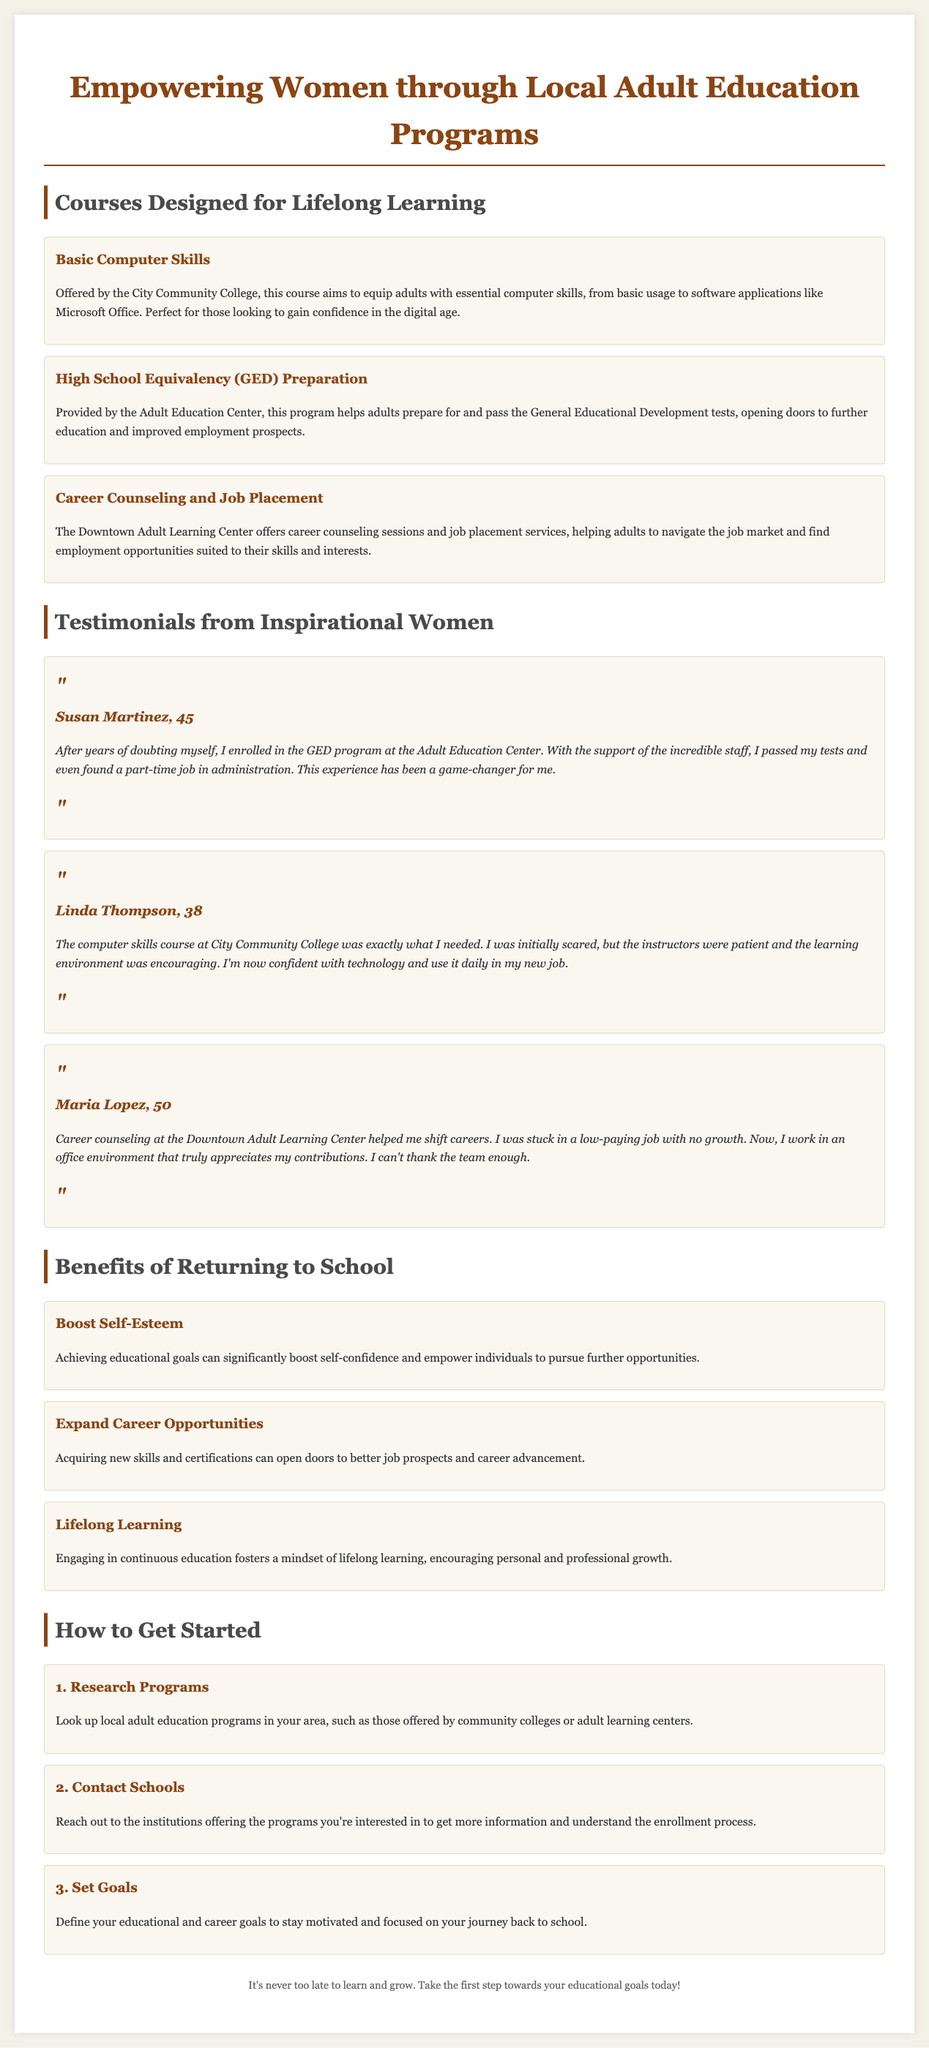What is the title of the document? The title is prominently displayed at the top of the document highlighting the main theme.
Answer: Empowering Women through Local Adult Education Programs How many courses are listed in the document? The document specifies three distinct courses offered for adult education.
Answer: 3 Who is the testimonial from Linda Thompson? The testimonial features an individual named Linda Thompson sharing her experience.
Answer: Linda Thompson What is one benefit of returning to school mentioned in the document? The document lists several benefits, one of which is prominently highlighted in the benefits section.
Answer: Boost Self-Esteem What is the first step to get started with adult education programs? The document outlines a specific order of steps to begin the process of returning to education.
Answer: Research Programs What age is Susan Martinez? The testimonial includes personal details such as age, specifically about Susan Martinez.
Answer: 45 Who offered the Career Counseling and Job Placement course? The document names the institution responsible for providing this course.
Answer: Downtown Adult Learning Center What was Maria Lopez's previous job situation? The testimonial from Maria Lopez provides insight into her career before attending the program.
Answer: Stuck in a low-paying job with no growth 